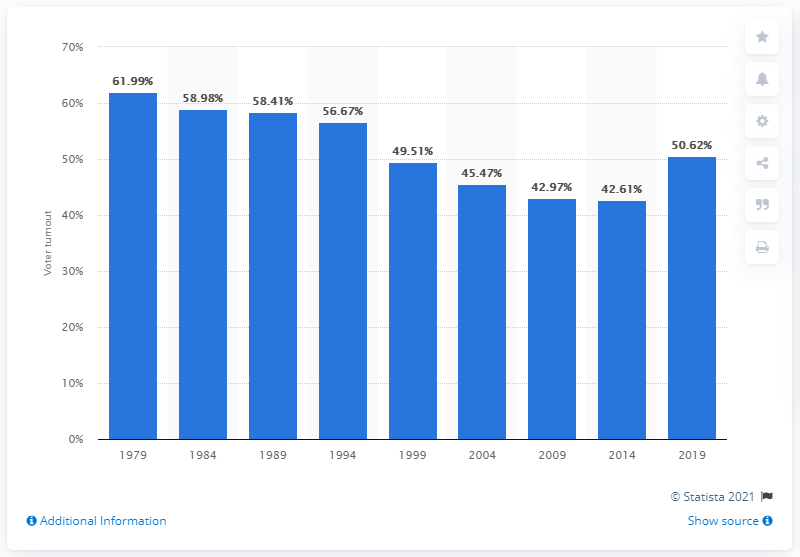Specify some key components in this picture. According to the data provided, it can be stated that in 2019, 49.51% of EU citizens cast their vote. In the year with the highest and lowest voter turnout in elections, 19.38% of people voted. The first set of European parliamentary elections were held in 1979. In 1979, the highest percentage of people voted in the European Parliament Elections. A total of 61.99% of eligible Europeans voted in the first set of European parliamentary elections. 